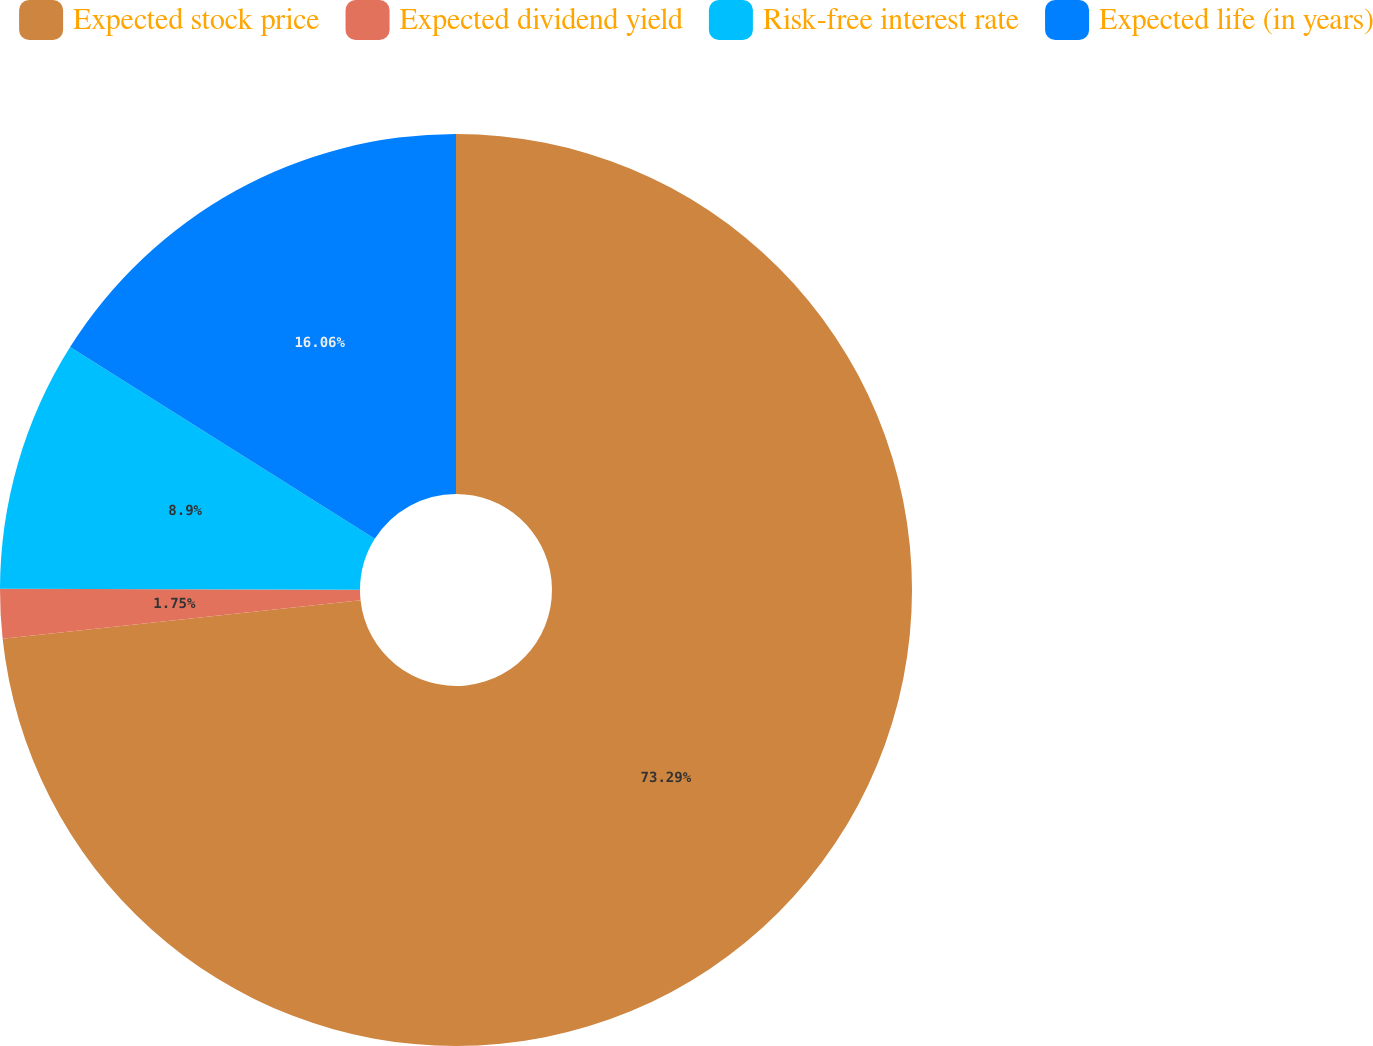Convert chart. <chart><loc_0><loc_0><loc_500><loc_500><pie_chart><fcel>Expected stock price<fcel>Expected dividend yield<fcel>Risk-free interest rate<fcel>Expected life (in years)<nl><fcel>73.3%<fcel>1.75%<fcel>8.9%<fcel>16.06%<nl></chart> 